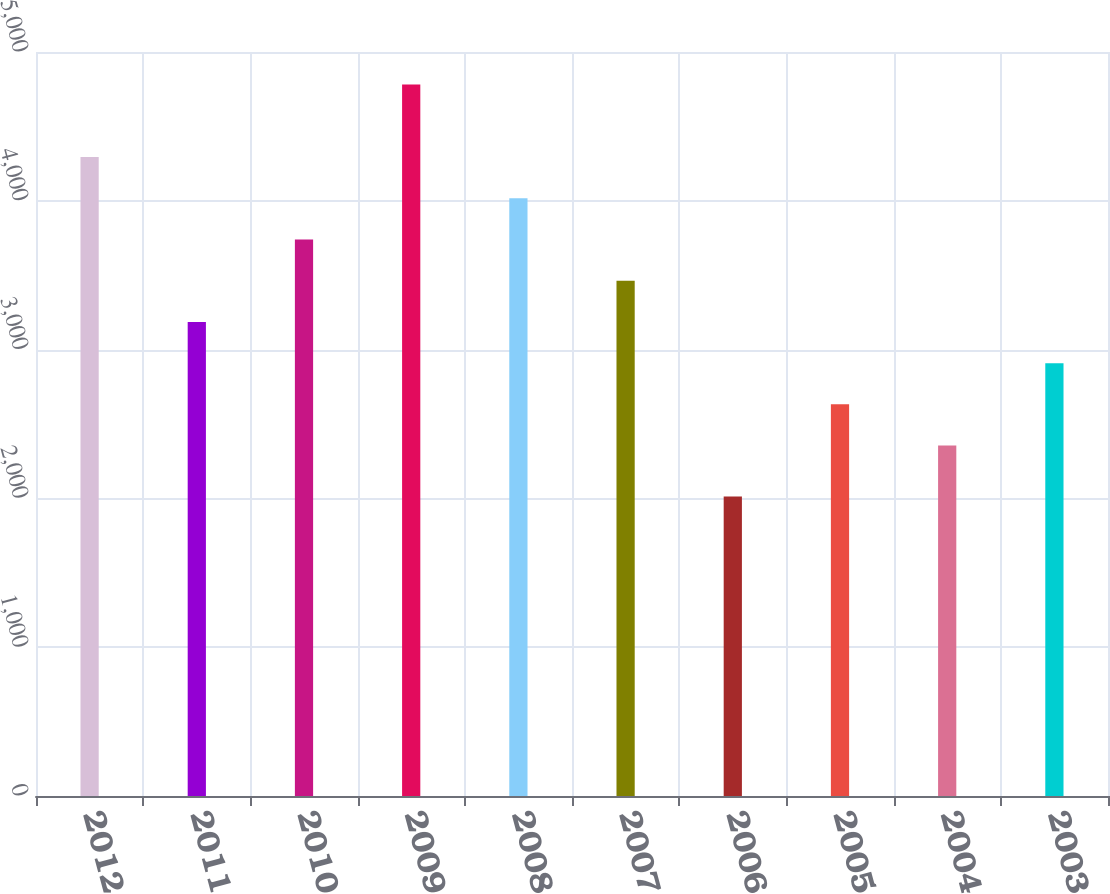Convert chart. <chart><loc_0><loc_0><loc_500><loc_500><bar_chart><fcel>2012<fcel>2011<fcel>2010<fcel>2009<fcel>2008<fcel>2007<fcel>2006<fcel>2005<fcel>2004<fcel>2003<nl><fcel>4294<fcel>3186<fcel>3740<fcel>4782<fcel>4017<fcel>3463<fcel>2012<fcel>2632<fcel>2355<fcel>2909<nl></chart> 